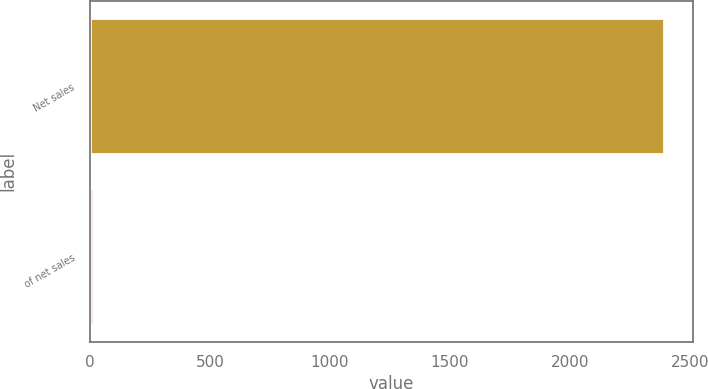Convert chart to OTSL. <chart><loc_0><loc_0><loc_500><loc_500><bar_chart><fcel>Net sales<fcel>of net sales<nl><fcel>2394.8<fcel>14.6<nl></chart> 